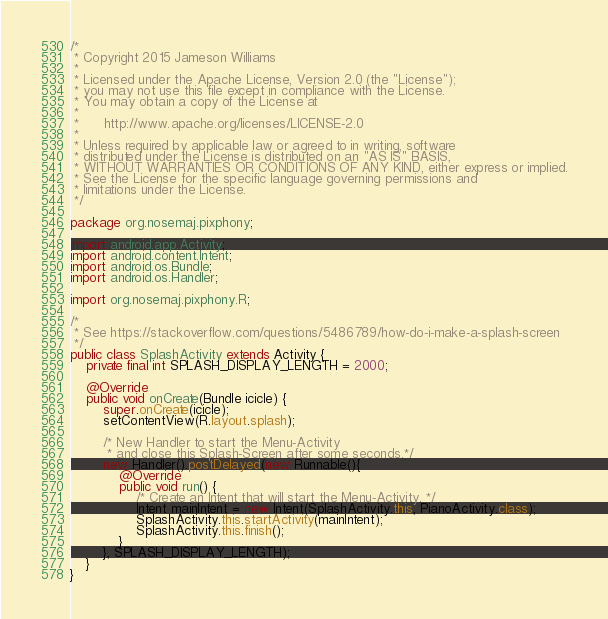<code> <loc_0><loc_0><loc_500><loc_500><_Java_>/*
 * Copyright 2015 Jameson Williams
 *
 * Licensed under the Apache License, Version 2.0 (the "License");
 * you may not use this file except in compliance with the License.
 * You may obtain a copy of the License at
 *
 *      http://www.apache.org/licenses/LICENSE-2.0
 *
 * Unless required by applicable law or agreed to in writing, software
 * distributed under the License is distributed on an "AS IS" BASIS,
 * WITHOUT WARRANTIES OR CONDITIONS OF ANY KIND, either express or implied.
 * See the License for the specific language governing permissions and
 * limitations under the License.
 */

package org.nosemaj.pixphony;
 
import android.app.Activity;
import android.content.Intent;
import android.os.Bundle;
import android.os.Handler;

import org.nosemaj.pixphony.R;

/*
 * See https://stackoverflow.com/questions/5486789/how-do-i-make-a-splash-screen
 */
public class SplashActivity extends Activity {
    private final int SPLASH_DISPLAY_LENGTH = 2000;

    @Override
    public void onCreate(Bundle icicle) {
        super.onCreate(icicle);
        setContentView(R.layout.splash);

        /* New Handler to start the Menu-Activity 
         * and close this Splash-Screen after some seconds.*/
        new Handler().postDelayed(new Runnable(){
            @Override
            public void run() {
                /* Create an Intent that will start the Menu-Activity. */
                Intent mainIntent = new Intent(SplashActivity.this, PianoActivity.class);
                SplashActivity.this.startActivity(mainIntent);
                SplashActivity.this.finish();
            }
        }, SPLASH_DISPLAY_LENGTH);
    }
}

</code> 